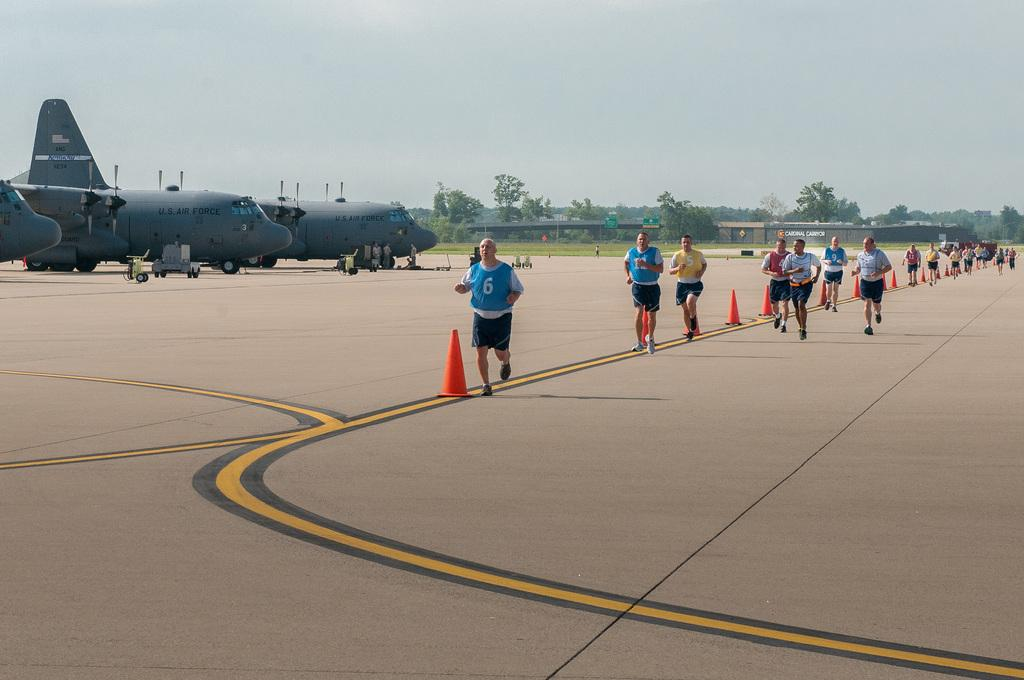<image>
Offer a succinct explanation of the picture presented. A person wearing a blue jersey with the number 6 runs in front of a group on a tarmac. 